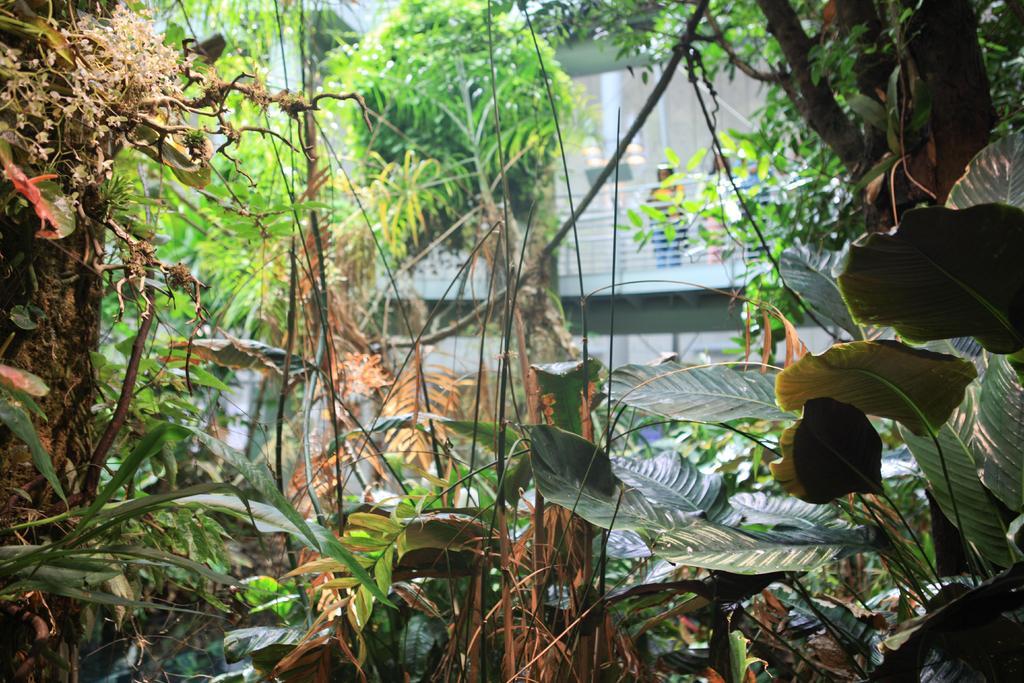Could you give a brief overview of what you see in this image? In this picture we can see trees and in the background we can see a building and some people standing. 